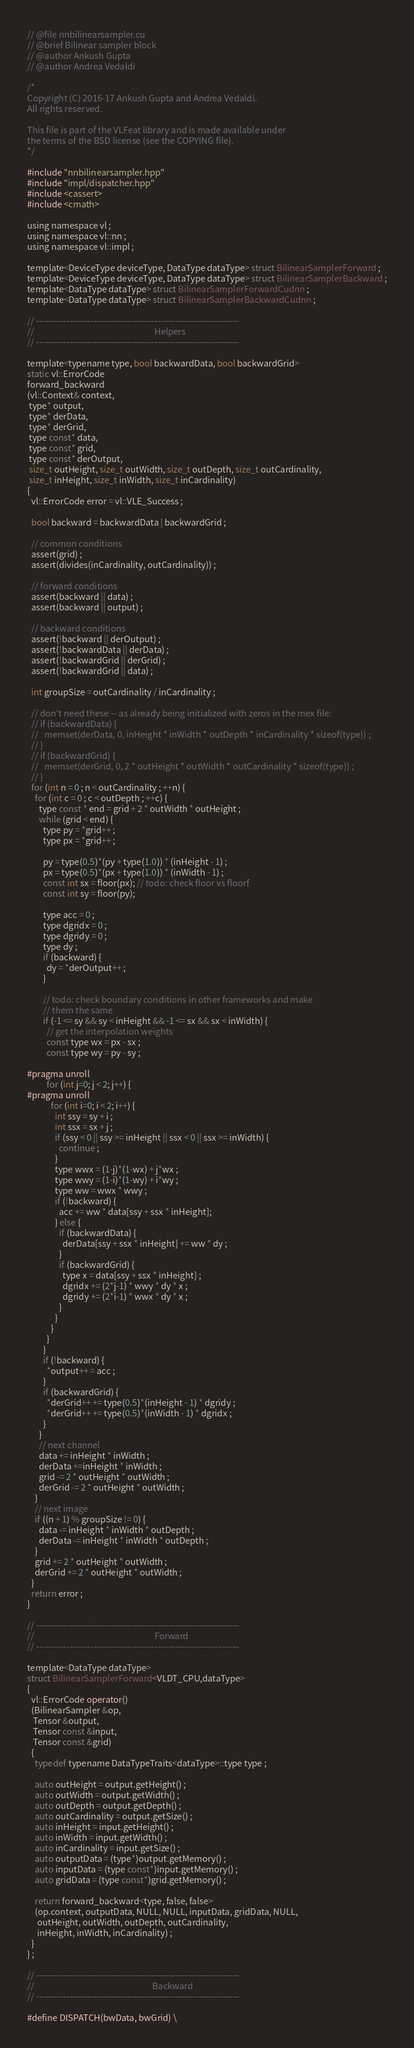Convert code to text. <code><loc_0><loc_0><loc_500><loc_500><_Cuda_>// @file nnbilinearsampler.cu
// @brief Bilinear sampler block
// @author Ankush Gupta
// @author Andrea Vedaldi

/*
Copyright (C) 2016-17 Ankush Gupta and Andrea Vedaldi.
All rights reserved.

This file is part of the VLFeat library and is made available under
the terms of the BSD license (see the COPYING file).
*/

#include "nnbilinearsampler.hpp"
#include "impl/dispatcher.hpp"
#include <cassert>
#include <cmath>

using namespace vl ;
using namespace vl::nn ;
using namespace vl::impl ;

template<DeviceType deviceType, DataType dataType> struct BilinearSamplerForward ;
template<DeviceType deviceType, DataType dataType> struct BilinearSamplerBackward ;
template<DataType dataType> struct BilinearSamplerForwardCudnn ;
template<DataType dataType> struct BilinearSamplerBackwardCudnn ;

// -------------------------------------------------------------------
//                                                             Helpers
// -------------------------------------------------------------------

template<typename type, bool backwardData, bool backwardGrid>
static vl::ErrorCode
forward_backward
(vl::Context& context,
 type* output,
 type* derData,
 type* derGrid,
 type const* data,
 type const* grid,
 type const* derOutput,
 size_t outHeight, size_t outWidth, size_t outDepth, size_t outCardinality,
 size_t inHeight, size_t inWidth, size_t inCardinality)
{
  vl::ErrorCode error = vl::VLE_Success ;

  bool backward = backwardData | backwardGrid ;

  // common conditions
  assert(grid) ;
  assert(divides(inCardinality, outCardinality)) ;

  // forward conditions
  assert(backward || data) ;
  assert(backward || output) ;

  // backward conditions
  assert(!backward || derOutput) ;
  assert(!backwardData || derData) ;
  assert(!backwardGrid || derGrid) ;
  assert(!backwardGrid || data) ;

  int groupSize = outCardinality / inCardinality ;

  // don't need these -- as already being initialized with zeros in the mex file:
  // if (backwardData) {
  //   memset(derData, 0, inHeight * inWidth * outDepth * inCardinality * sizeof(type)) ;
  // }
  // if (backwardGrid) {
  //   memset(derGrid, 0, 2 * outHeight * outWidth * outCardinality * sizeof(type)) ;
  // }
  for (int n = 0 ; n < outCardinality ; ++n) {
    for (int c = 0 ; c < outDepth ; ++c) {
      type const * end = grid + 2 * outWidth * outHeight ;
      while (grid < end) {
        type py = *grid++ ;
        type px = *grid++ ;

        py = type(0.5)*(py + type(1.0)) * (inHeight - 1) ;
        px = type(0.5)*(px + type(1.0)) * (inWidth - 1) ;
        const int sx = floor(px); // todo: check floor vs floorf
        const int sy = floor(py);

        type acc = 0 ;
        type dgridx = 0 ;
        type dgridy = 0 ;
        type dy ;
        if (backward) {
          dy = *derOutput++ ;
        }

        // todo: check boundary conditions in other frameworks and make
        // them the same
        if (-1 <= sy && sy < inHeight && -1 <= sx && sx < inWidth) {
          // get the interpolation weights
          const type wx = px - sx ;
          const type wy = py - sy ;

#pragma unroll
          for (int j=0; j < 2; j++) {
#pragma unroll
            for (int i=0; i < 2; i++) {
              int ssy = sy + i ;
              int ssx = sx + j ;
              if (ssy < 0 || ssy >= inHeight || ssx < 0 || ssx >= inWidth) {
                continue ;
              }
              type wwx = (1-j)*(1-wx) + j*wx ;
              type wwy = (1-i)*(1-wy) + i*wy ;
              type ww = wwx * wwy ;
              if (!backward) {
                acc += ww * data[ssy + ssx * inHeight];
              } else {
                if (backwardData) {
                  derData[ssy + ssx * inHeight] += ww * dy ;
                }
                if (backwardGrid) {
                  type x = data[ssy + ssx * inHeight] ;
                  dgridx += (2*j-1) * wwy * dy * x ;
                  dgridy += (2*i-1) * wwx * dy * x ;
                }
              }
            }
          }
        }
        if (!backward) {
          *output++ = acc ;
        }
        if (backwardGrid) {
          *derGrid++ += type(0.5)*(inHeight - 1) * dgridy ;
          *derGrid++ += type(0.5)*(inWidth - 1) * dgridx ;
        }
      }
      // next channel
      data += inHeight * inWidth ;
      derData +=inHeight * inWidth ;
      grid -= 2 * outHeight * outWidth ;
      derGrid -= 2 * outHeight * outWidth ;
    }
    // next image
    if ((n + 1) % groupSize != 0) {
      data -= inHeight * inWidth * outDepth ;
      derData -= inHeight * inWidth * outDepth ;
    }
    grid += 2 * outHeight * outWidth ;
    derGrid += 2 * outHeight * outWidth ;
  }
  return error ;
}

// -------------------------------------------------------------------
//                                                             Forward
// -------------------------------------------------------------------

template<DataType dataType>
struct BilinearSamplerForward<VLDT_CPU,dataType>
{
  vl::ErrorCode operator()
  (BilinearSampler &op,
   Tensor &output,
   Tensor const &input,
   Tensor const &grid)
  {
    typedef typename DataTypeTraits<dataType>::type type ;

    auto outHeight = output.getHeight() ;
    auto outWidth = output.getWidth() ;
    auto outDepth = output.getDepth() ;
    auto outCardinality = output.getSize() ;
    auto inHeight = input.getHeight() ;
    auto inWidth = input.getWidth() ;
    auto inCardinality = input.getSize() ;
    auto outputData = (type*)output.getMemory() ;
    auto inputData = (type const*)input.getMemory() ;
    auto gridData = (type const*)grid.getMemory() ;

    return forward_backward<type, false, false>
    (op.context, outputData, NULL, NULL, inputData, gridData, NULL,
     outHeight, outWidth, outDepth, outCardinality,
     inHeight, inWidth, inCardinality) ;
  }
} ;

// -------------------------------------------------------------------
//                                                            Backward
// -------------------------------------------------------------------

#define DISPATCH(bwData, bwGrid) \</code> 